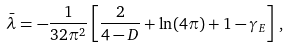<formula> <loc_0><loc_0><loc_500><loc_500>\bar { \lambda } = - \frac { 1 } { 3 2 \pi ^ { 2 } } \left [ \frac { 2 } { 4 - D } + \ln ( 4 \pi ) + 1 - \gamma _ { E } \right ] \, ,</formula> 